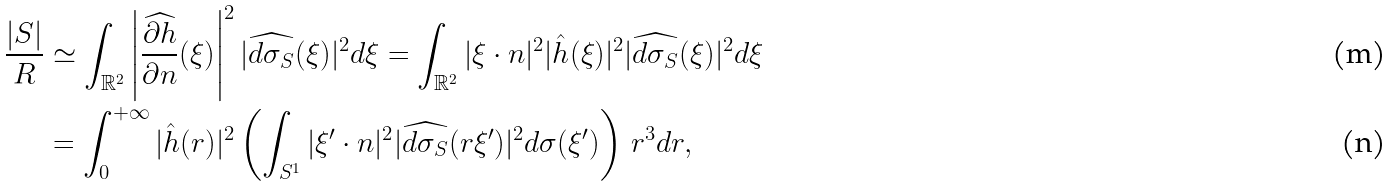<formula> <loc_0><loc_0><loc_500><loc_500>\frac { | S | } { R } & \simeq \int _ { \mathbb { R } ^ { 2 } } \left | \widehat { \frac { \partial h } { \partial n } } ( \xi ) \right | ^ { 2 } | \widehat { d \sigma _ { S } } ( \xi ) | ^ { 2 } d \xi = \int _ { \mathbb { R } ^ { 2 } } | \xi \cdot n | ^ { 2 } | \hat { h } ( \xi ) | ^ { 2 } | \widehat { d \sigma _ { S } } ( \xi ) | ^ { 2 } d \xi \\ & = \int _ { 0 } ^ { + \infty } | \hat { h } ( r ) | ^ { 2 } \left ( \int _ { S ^ { 1 } } | \xi ^ { \prime } \cdot n | ^ { 2 } | \widehat { d \sigma _ { S } } ( r \xi ^ { \prime } ) | ^ { 2 } d \sigma ( \xi ^ { \prime } ) \right ) \, r ^ { 3 } d r ,</formula> 